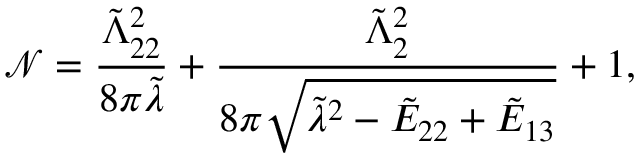<formula> <loc_0><loc_0><loc_500><loc_500>\mathcal { N } = \frac { \tilde { \Lambda } _ { 2 2 } ^ { 2 } } { 8 \pi \tilde { \lambda } } + \frac { \tilde { \Lambda } _ { 2 } ^ { 2 } } { 8 \pi \sqrt { \tilde { \lambda } ^ { 2 } - \tilde { E } _ { 2 2 } + \tilde { E } _ { 1 3 } } } + 1 ,</formula> 